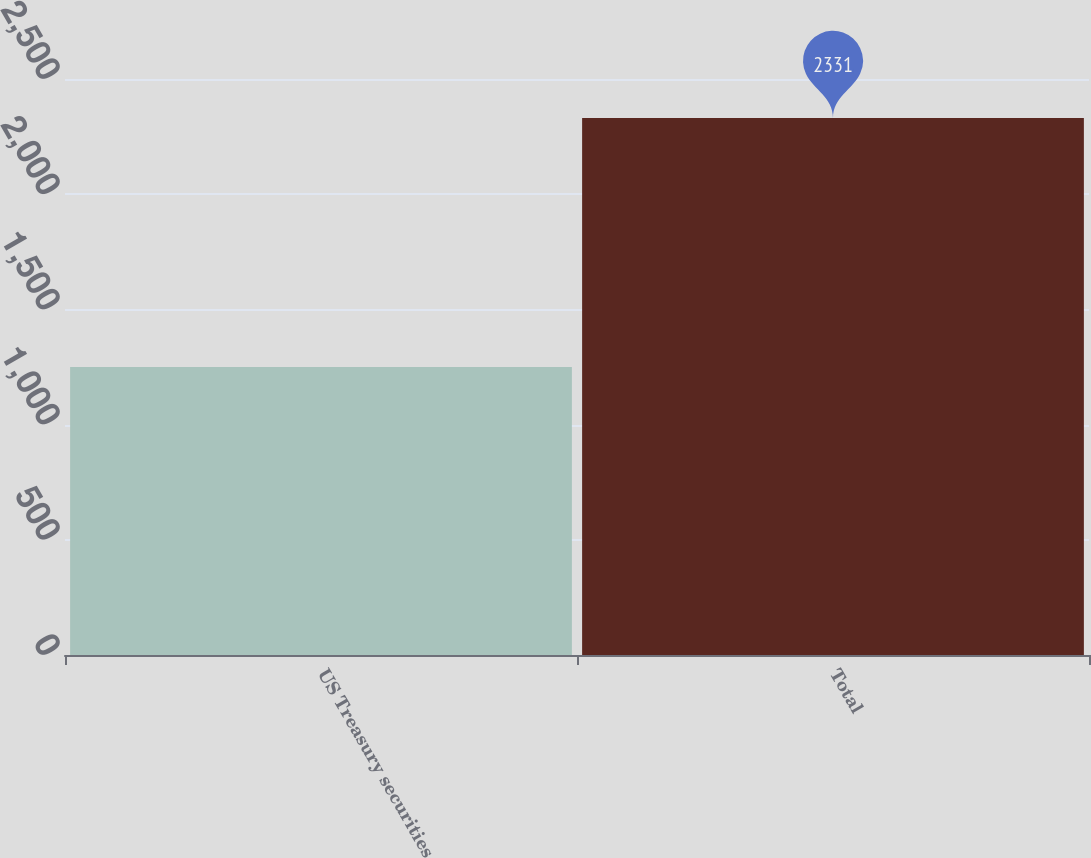<chart> <loc_0><loc_0><loc_500><loc_500><bar_chart><fcel>US Treasury securities<fcel>Total<nl><fcel>1250<fcel>2331<nl></chart> 